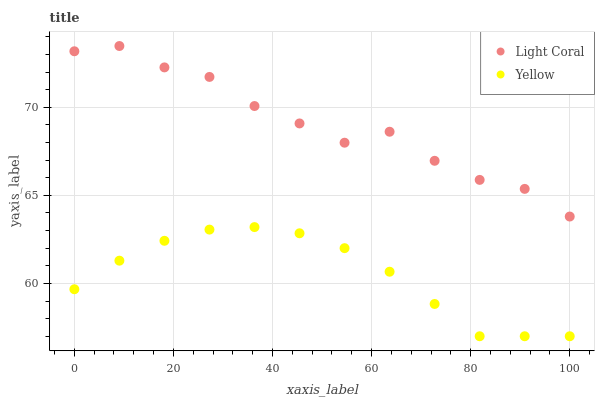Does Yellow have the minimum area under the curve?
Answer yes or no. Yes. Does Light Coral have the maximum area under the curve?
Answer yes or no. Yes. Does Yellow have the maximum area under the curve?
Answer yes or no. No. Is Yellow the smoothest?
Answer yes or no. Yes. Is Light Coral the roughest?
Answer yes or no. Yes. Is Yellow the roughest?
Answer yes or no. No. Does Yellow have the lowest value?
Answer yes or no. Yes. Does Light Coral have the highest value?
Answer yes or no. Yes. Does Yellow have the highest value?
Answer yes or no. No. Is Yellow less than Light Coral?
Answer yes or no. Yes. Is Light Coral greater than Yellow?
Answer yes or no. Yes. Does Yellow intersect Light Coral?
Answer yes or no. No. 